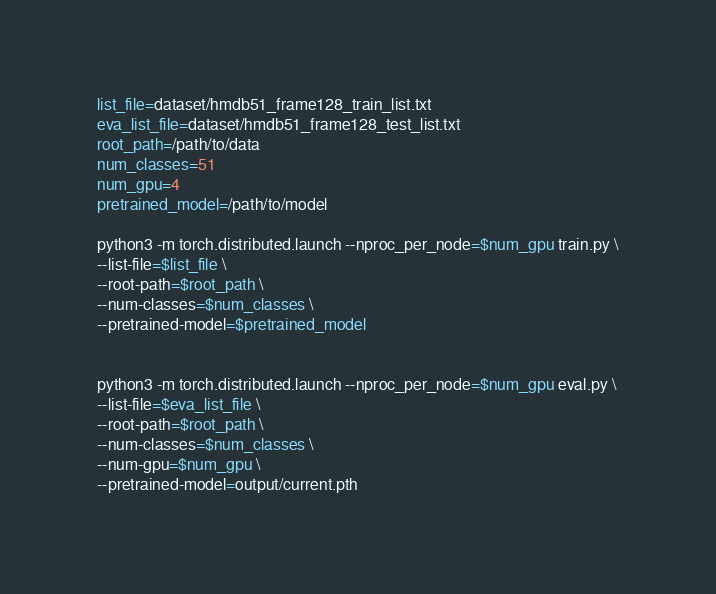<code> <loc_0><loc_0><loc_500><loc_500><_Bash_>list_file=dataset/hmdb51_frame128_train_list.txt
eva_list_file=dataset/hmdb51_frame128_test_list.txt
root_path=/path/to/data
num_classes=51
num_gpu=4
pretrained_model=/path/to/model

python3 -m torch.distributed.launch --nproc_per_node=$num_gpu train.py \
--list-file=$list_file \
--root-path=$root_path \
--num-classes=$num_classes \
--pretrained-model=$pretrained_model


python3 -m torch.distributed.launch --nproc_per_node=$num_gpu eval.py \
--list-file=$eva_list_file \
--root-path=$root_path \
--num-classes=$num_classes \
--num-gpu=$num_gpu \
--pretrained-model=output/current.pth


</code> 